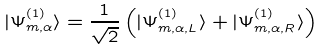<formula> <loc_0><loc_0><loc_500><loc_500>| \Psi ^ { ( 1 ) } _ { m , \alpha } \rangle = \frac { 1 } { \sqrt { 2 } } \left ( | \Psi ^ { ( 1 ) } _ { m , \alpha , L } \rangle + | \Psi ^ { ( 1 ) } _ { m , \alpha , R } \rangle \right )</formula> 